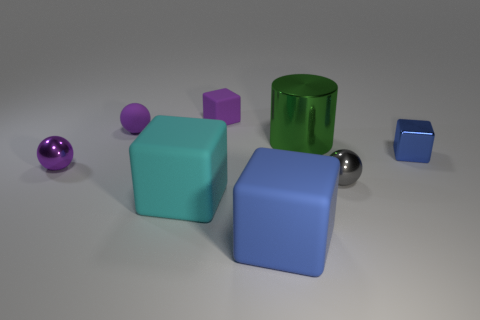Are there any large cyan cubes that are behind the cube to the right of the tiny shiny sphere on the right side of the tiny purple rubber sphere?
Offer a very short reply. No. Does the small blue thing have the same shape as the large cyan object?
Offer a very short reply. Yes. Are there fewer tiny purple rubber blocks that are in front of the gray metal sphere than big blocks?
Provide a succinct answer. Yes. The metal sphere that is behind the small metallic sphere that is in front of the small shiny ball that is left of the big cyan rubber cube is what color?
Make the answer very short. Purple. How many metallic things are either large cubes or big blue cubes?
Make the answer very short. 0. Does the blue metal object have the same size as the cylinder?
Offer a terse response. No. Are there fewer large green metal things that are in front of the green object than tiny purple matte things that are on the left side of the matte ball?
Provide a short and direct response. No. Is there any other thing that is the same size as the cylinder?
Offer a very short reply. Yes. What is the size of the blue metal thing?
Offer a terse response. Small. How many tiny objects are either cylinders or brown rubber cubes?
Your answer should be compact. 0. 